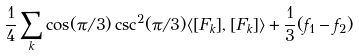<formula> <loc_0><loc_0><loc_500><loc_500>\frac { 1 } { 4 } \sum _ { k } \cos ( { \pi / 3 } ) \csc ^ { 2 } ( { \pi / 3 } ) \langle [ F _ { k } ] , [ F _ { k } ] \rangle + \frac { 1 } { 3 } ( f _ { 1 } - f _ { 2 } )</formula> 